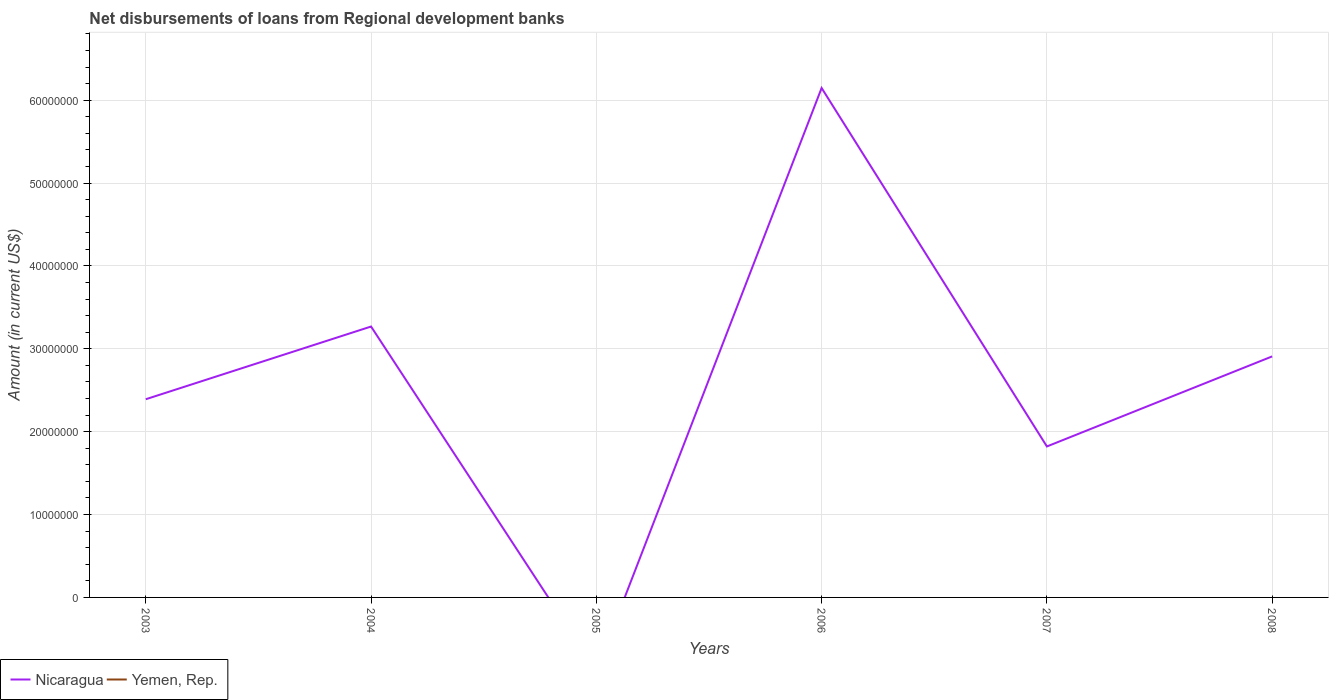How many different coloured lines are there?
Ensure brevity in your answer.  1. Does the line corresponding to Yemen, Rep. intersect with the line corresponding to Nicaragua?
Make the answer very short. No. What is the total amount of disbursements of loans from regional development banks in Nicaragua in the graph?
Provide a succinct answer. -5.17e+06. What is the difference between the highest and the second highest amount of disbursements of loans from regional development banks in Nicaragua?
Your response must be concise. 6.15e+07. What is the difference between the highest and the lowest amount of disbursements of loans from regional development banks in Nicaragua?
Make the answer very short. 3. Is the amount of disbursements of loans from regional development banks in Yemen, Rep. strictly greater than the amount of disbursements of loans from regional development banks in Nicaragua over the years?
Your response must be concise. Yes. How many years are there in the graph?
Offer a terse response. 6. What is the difference between two consecutive major ticks on the Y-axis?
Your answer should be very brief. 1.00e+07. Are the values on the major ticks of Y-axis written in scientific E-notation?
Offer a very short reply. No. Does the graph contain grids?
Your answer should be very brief. Yes. Where does the legend appear in the graph?
Your answer should be compact. Bottom left. How many legend labels are there?
Your response must be concise. 2. What is the title of the graph?
Your answer should be compact. Net disbursements of loans from Regional development banks. Does "Timor-Leste" appear as one of the legend labels in the graph?
Your answer should be very brief. No. What is the label or title of the X-axis?
Your answer should be very brief. Years. What is the Amount (in current US$) of Nicaragua in 2003?
Your response must be concise. 2.39e+07. What is the Amount (in current US$) of Yemen, Rep. in 2003?
Offer a terse response. 0. What is the Amount (in current US$) in Nicaragua in 2004?
Give a very brief answer. 3.27e+07. What is the Amount (in current US$) in Nicaragua in 2005?
Give a very brief answer. 0. What is the Amount (in current US$) in Nicaragua in 2006?
Offer a very short reply. 6.15e+07. What is the Amount (in current US$) of Yemen, Rep. in 2006?
Your answer should be very brief. 0. What is the Amount (in current US$) in Nicaragua in 2007?
Give a very brief answer. 1.82e+07. What is the Amount (in current US$) of Nicaragua in 2008?
Give a very brief answer. 2.91e+07. What is the Amount (in current US$) of Yemen, Rep. in 2008?
Your answer should be compact. 0. Across all years, what is the maximum Amount (in current US$) of Nicaragua?
Your answer should be compact. 6.15e+07. Across all years, what is the minimum Amount (in current US$) in Nicaragua?
Ensure brevity in your answer.  0. What is the total Amount (in current US$) of Nicaragua in the graph?
Offer a very short reply. 1.65e+08. What is the total Amount (in current US$) of Yemen, Rep. in the graph?
Provide a short and direct response. 0. What is the difference between the Amount (in current US$) of Nicaragua in 2003 and that in 2004?
Offer a terse response. -8.78e+06. What is the difference between the Amount (in current US$) in Nicaragua in 2003 and that in 2006?
Offer a very short reply. -3.76e+07. What is the difference between the Amount (in current US$) in Nicaragua in 2003 and that in 2007?
Provide a succinct answer. 5.70e+06. What is the difference between the Amount (in current US$) of Nicaragua in 2003 and that in 2008?
Keep it short and to the point. -5.17e+06. What is the difference between the Amount (in current US$) in Nicaragua in 2004 and that in 2006?
Your response must be concise. -2.88e+07. What is the difference between the Amount (in current US$) of Nicaragua in 2004 and that in 2007?
Offer a very short reply. 1.45e+07. What is the difference between the Amount (in current US$) in Nicaragua in 2004 and that in 2008?
Your response must be concise. 3.61e+06. What is the difference between the Amount (in current US$) in Nicaragua in 2006 and that in 2007?
Make the answer very short. 4.33e+07. What is the difference between the Amount (in current US$) in Nicaragua in 2006 and that in 2008?
Keep it short and to the point. 3.24e+07. What is the difference between the Amount (in current US$) of Nicaragua in 2007 and that in 2008?
Ensure brevity in your answer.  -1.09e+07. What is the average Amount (in current US$) of Nicaragua per year?
Your response must be concise. 2.76e+07. What is the ratio of the Amount (in current US$) of Nicaragua in 2003 to that in 2004?
Provide a short and direct response. 0.73. What is the ratio of the Amount (in current US$) in Nicaragua in 2003 to that in 2006?
Offer a very short reply. 0.39. What is the ratio of the Amount (in current US$) of Nicaragua in 2003 to that in 2007?
Your answer should be very brief. 1.31. What is the ratio of the Amount (in current US$) of Nicaragua in 2003 to that in 2008?
Your answer should be very brief. 0.82. What is the ratio of the Amount (in current US$) of Nicaragua in 2004 to that in 2006?
Keep it short and to the point. 0.53. What is the ratio of the Amount (in current US$) in Nicaragua in 2004 to that in 2007?
Offer a very short reply. 1.79. What is the ratio of the Amount (in current US$) in Nicaragua in 2004 to that in 2008?
Your response must be concise. 1.12. What is the ratio of the Amount (in current US$) in Nicaragua in 2006 to that in 2007?
Your response must be concise. 3.37. What is the ratio of the Amount (in current US$) in Nicaragua in 2006 to that in 2008?
Ensure brevity in your answer.  2.11. What is the ratio of the Amount (in current US$) of Nicaragua in 2007 to that in 2008?
Your answer should be very brief. 0.63. What is the difference between the highest and the second highest Amount (in current US$) of Nicaragua?
Your answer should be very brief. 2.88e+07. What is the difference between the highest and the lowest Amount (in current US$) in Nicaragua?
Provide a succinct answer. 6.15e+07. 